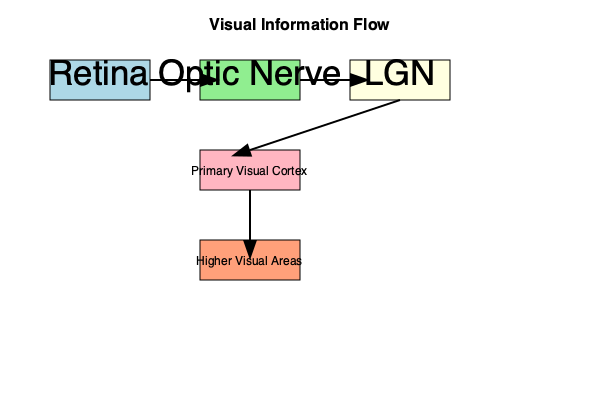As a science columnist preparing for a neuroscience event, you're reviewing the visual processing pathway. In the flowchart above, which structure receives visual information directly from the retina and serves as a crucial relay station before the signal reaches the primary visual cortex? To answer this question, let's follow the visual information flow step-by-step:

1. The visual process begins at the retina, where light is converted into electrical signals.

2. These signals then travel through the optic nerve, which carries the information from the retina to the next structure.

3. After the optic nerve, we see that the information flows directly to a structure labeled "LGN" (Lateral Geniculate Nucleus).

4. From the LGN, the information is then relayed to the primary visual cortex.

5. The LGN, therefore, acts as an intermediary station between the initial reception of visual information (retina) and the primary processing area (primary visual cortex).

6. This makes the LGN a crucial relay station in the visual pathway, receiving direct input from the retina and projecting to the primary visual cortex.

7. After the primary visual cortex, information is further processed in higher visual areas.

The structure that fits the description in the question - receiving information directly from the retina and serving as a relay before the primary visual cortex - is the LGN (Lateral Geniculate Nucleus).
Answer: LGN (Lateral Geniculate Nucleus) 